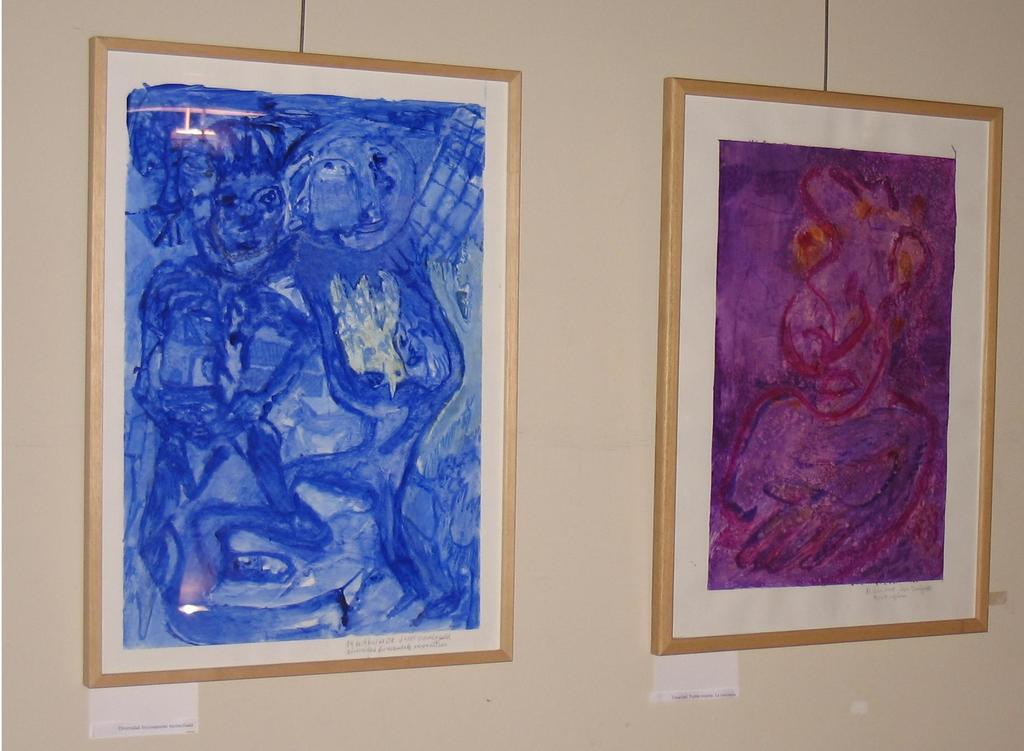What is present on the wall in the image? There are two paintings in the image. How are the paintings displayed on the wall? The paintings have frames. Can you see a kite being flown by the grandfather in the image? There is no kite or grandfather present in the image; it only features two paintings on a wall. Is the painting being kicked by someone in the image? There is no indication of anyone kicking the painting in the image. 